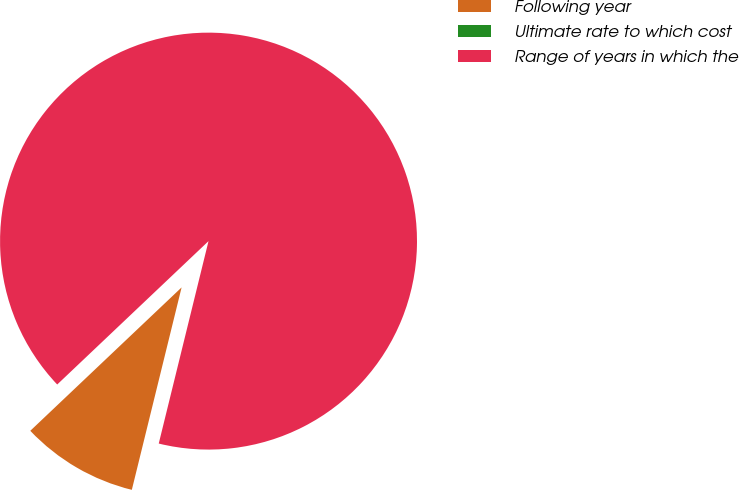Convert chart. <chart><loc_0><loc_0><loc_500><loc_500><pie_chart><fcel>Following year<fcel>Ultimate rate to which cost<fcel>Range of years in which the<nl><fcel>9.09%<fcel>0.0%<fcel>90.91%<nl></chart> 